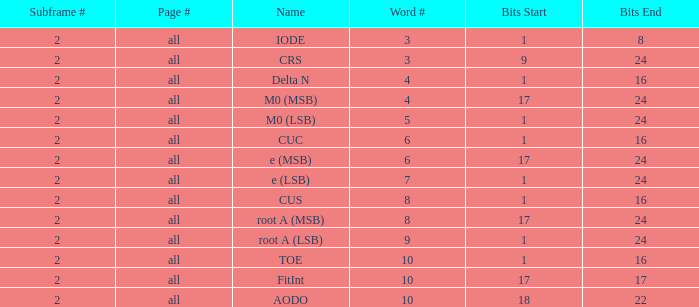For 18-22 bits, what are the total pages and the word count greater than 5? All. 